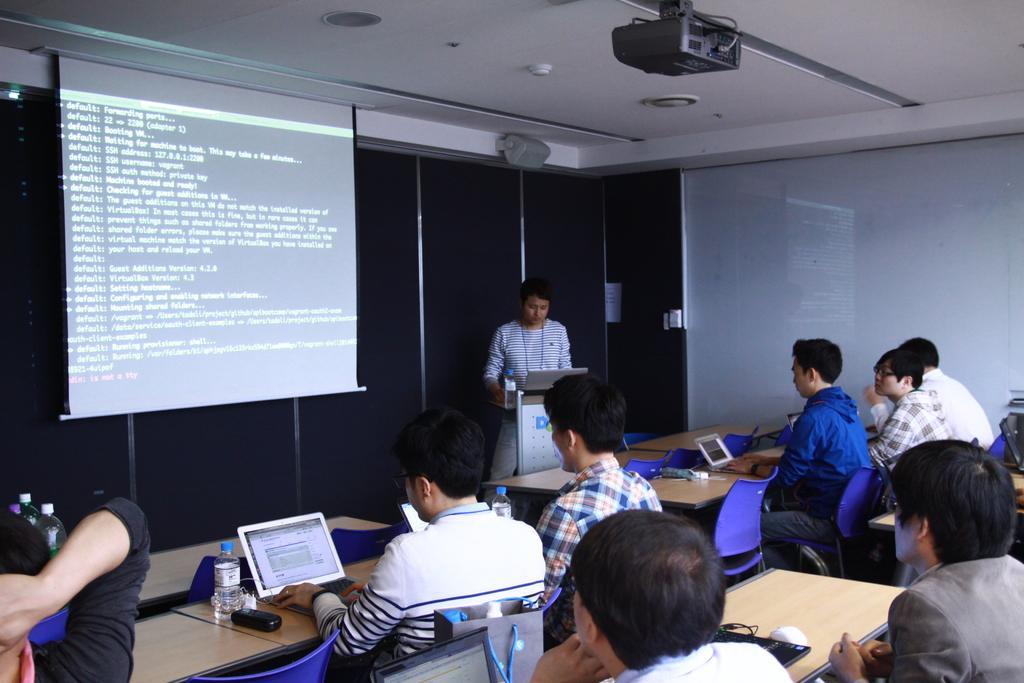Describe this image in one or two sentences. In this image at the bottom there are group of people who are sitting and also there are some tables, on the tables there are some bottles, laptops and some other objects. And on the left side there is one screen, and in the background there is another person who is standing and he is holding a laptop at the top there is ceiling and projector. 